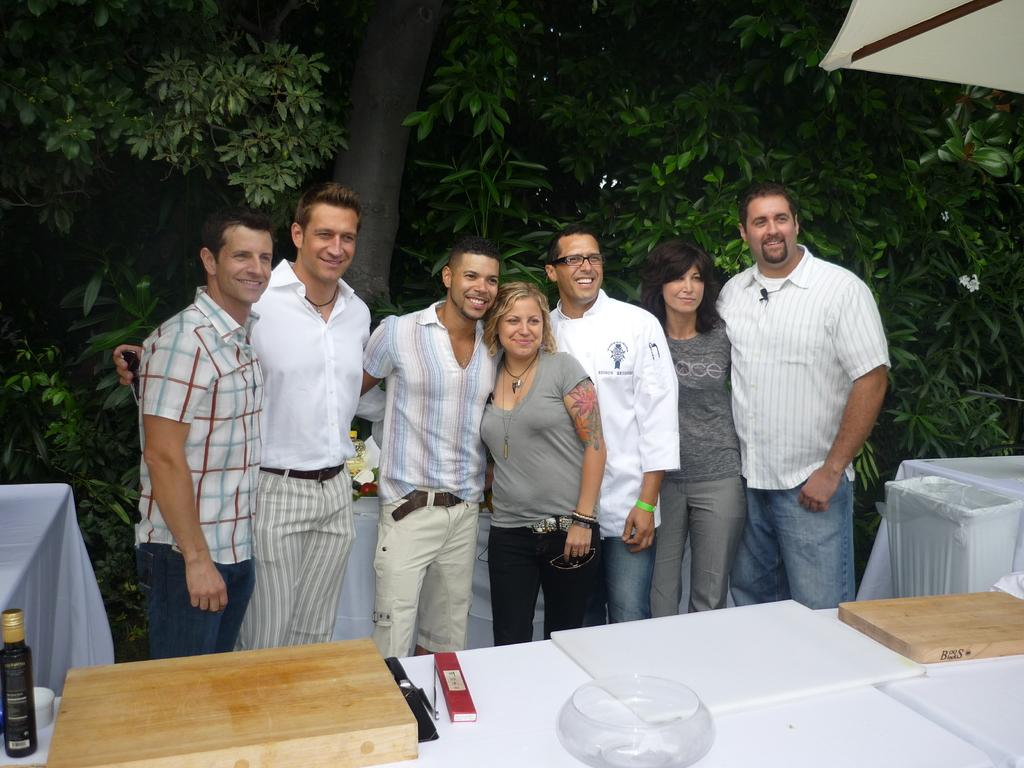What type of vegetation can be seen in the image? There are trees in the image. What else is present in the image besides the trees? There are people standing in the image, as well as a table. What is on the table in the image? There is a bottle on the table in the image. How many scarecrows are present in the image? There are no scarecrows present in the image. What type of lizards can be seen crawling on the people in the image? There are no lizards present in the image, and the people are not being crawled on by any creatures. 